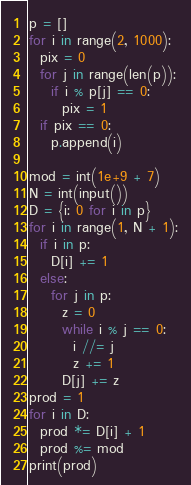Convert code to text. <code><loc_0><loc_0><loc_500><loc_500><_Python_>p = []
for i in range(2, 1000):
  pix = 0
  for j in range(len(p)):
    if i % p[j] == 0:
      pix = 1
  if pix == 0:
    p.append(i)

mod = int(1e+9 + 7)
N = int(input())
D = {i: 0 for i in p}
for i in range(1, N + 1):
  if i in p:
    D[i] += 1
  else:
    for j in p:
      z = 0
      while i % j == 0:
        i //= j
        z += 1
      D[j] += z
prod = 1
for i in D:
  prod *= D[i] + 1
  prod %= mod
print(prod)</code> 